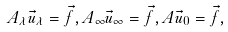<formula> <loc_0><loc_0><loc_500><loc_500>A _ { \lambda } \vec { u } _ { \lambda } = \vec { f } , A _ { \infty } \vec { u } _ { \infty } = \vec { f } , A \vec { u } _ { 0 } = \vec { f } ,</formula> 